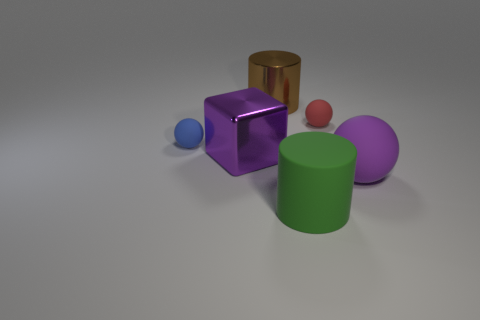There is a blue object that is the same size as the red ball; what is its shape?
Your answer should be compact. Sphere. What number of other things are there of the same color as the matte cylinder?
Your answer should be very brief. 0. What is the material of the big green object?
Make the answer very short. Rubber. How many other things are the same material as the large purple sphere?
Your response must be concise. 3. What is the size of the object that is both to the left of the red ball and behind the blue matte ball?
Ensure brevity in your answer.  Large. What shape is the shiny thing that is behind the small matte thing right of the big block?
Make the answer very short. Cylinder. Is there anything else that has the same shape as the tiny red thing?
Provide a succinct answer. Yes. Are there an equal number of big purple cubes that are on the right side of the large brown object and big cyan rubber blocks?
Ensure brevity in your answer.  Yes. Is the color of the block the same as the big matte thing behind the big rubber cylinder?
Provide a short and direct response. Yes. What color is the big thing that is to the left of the green thing and in front of the metal cylinder?
Your answer should be very brief. Purple. 